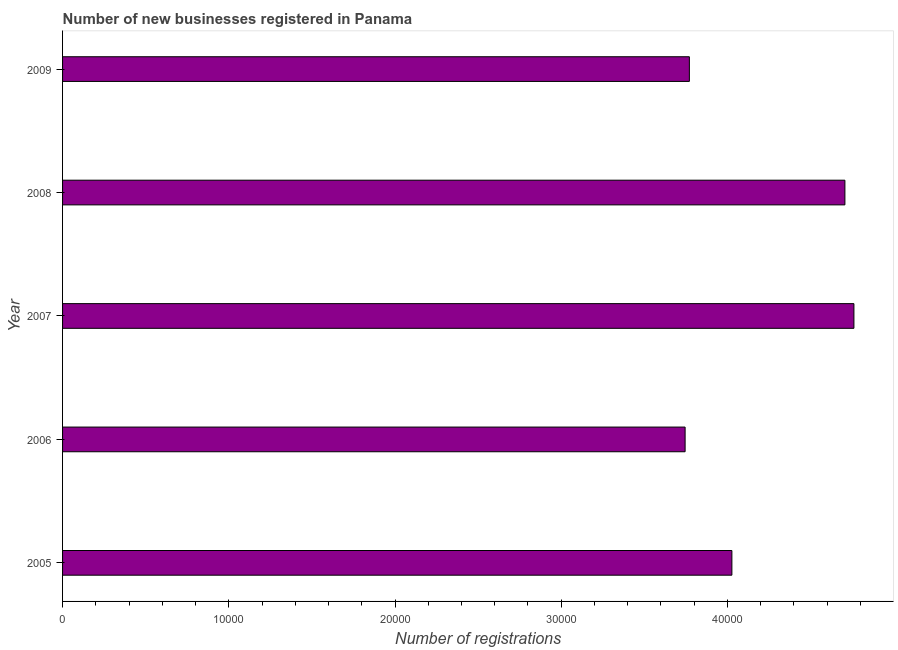Does the graph contain grids?
Keep it short and to the point. No. What is the title of the graph?
Your response must be concise. Number of new businesses registered in Panama. What is the label or title of the X-axis?
Your response must be concise. Number of registrations. What is the label or title of the Y-axis?
Your response must be concise. Year. What is the number of new business registrations in 2006?
Offer a terse response. 3.75e+04. Across all years, what is the maximum number of new business registrations?
Offer a very short reply. 4.76e+04. Across all years, what is the minimum number of new business registrations?
Provide a short and direct response. 3.75e+04. What is the sum of the number of new business registrations?
Give a very brief answer. 2.10e+05. What is the difference between the number of new business registrations in 2005 and 2006?
Offer a terse response. 2814. What is the average number of new business registrations per year?
Give a very brief answer. 4.20e+04. What is the median number of new business registrations?
Give a very brief answer. 4.03e+04. Do a majority of the years between 2006 and 2007 (inclusive) have number of new business registrations greater than 46000 ?
Your answer should be very brief. No. What is the ratio of the number of new business registrations in 2007 to that in 2008?
Your response must be concise. 1.01. Is the difference between the number of new business registrations in 2005 and 2007 greater than the difference between any two years?
Give a very brief answer. No. What is the difference between the highest and the second highest number of new business registrations?
Ensure brevity in your answer.  543. What is the difference between the highest and the lowest number of new business registrations?
Your answer should be compact. 1.02e+04. In how many years, is the number of new business registrations greater than the average number of new business registrations taken over all years?
Make the answer very short. 2. How many bars are there?
Your response must be concise. 5. Are all the bars in the graph horizontal?
Offer a terse response. Yes. How many years are there in the graph?
Make the answer very short. 5. What is the difference between two consecutive major ticks on the X-axis?
Give a very brief answer. 10000. Are the values on the major ticks of X-axis written in scientific E-notation?
Provide a short and direct response. No. What is the Number of registrations of 2005?
Give a very brief answer. 4.03e+04. What is the Number of registrations in 2006?
Provide a succinct answer. 3.75e+04. What is the Number of registrations in 2007?
Give a very brief answer. 4.76e+04. What is the Number of registrations of 2008?
Provide a short and direct response. 4.71e+04. What is the Number of registrations of 2009?
Offer a very short reply. 3.77e+04. What is the difference between the Number of registrations in 2005 and 2006?
Offer a terse response. 2814. What is the difference between the Number of registrations in 2005 and 2007?
Provide a succinct answer. -7342. What is the difference between the Number of registrations in 2005 and 2008?
Your response must be concise. -6799. What is the difference between the Number of registrations in 2005 and 2009?
Offer a very short reply. 2558. What is the difference between the Number of registrations in 2006 and 2007?
Your response must be concise. -1.02e+04. What is the difference between the Number of registrations in 2006 and 2008?
Make the answer very short. -9613. What is the difference between the Number of registrations in 2006 and 2009?
Provide a short and direct response. -256. What is the difference between the Number of registrations in 2007 and 2008?
Your response must be concise. 543. What is the difference between the Number of registrations in 2007 and 2009?
Ensure brevity in your answer.  9900. What is the difference between the Number of registrations in 2008 and 2009?
Keep it short and to the point. 9357. What is the ratio of the Number of registrations in 2005 to that in 2006?
Your answer should be very brief. 1.07. What is the ratio of the Number of registrations in 2005 to that in 2007?
Keep it short and to the point. 0.85. What is the ratio of the Number of registrations in 2005 to that in 2008?
Keep it short and to the point. 0.86. What is the ratio of the Number of registrations in 2005 to that in 2009?
Provide a succinct answer. 1.07. What is the ratio of the Number of registrations in 2006 to that in 2007?
Give a very brief answer. 0.79. What is the ratio of the Number of registrations in 2006 to that in 2008?
Your answer should be compact. 0.8. What is the ratio of the Number of registrations in 2007 to that in 2008?
Provide a short and direct response. 1.01. What is the ratio of the Number of registrations in 2007 to that in 2009?
Give a very brief answer. 1.26. What is the ratio of the Number of registrations in 2008 to that in 2009?
Your answer should be compact. 1.25. 